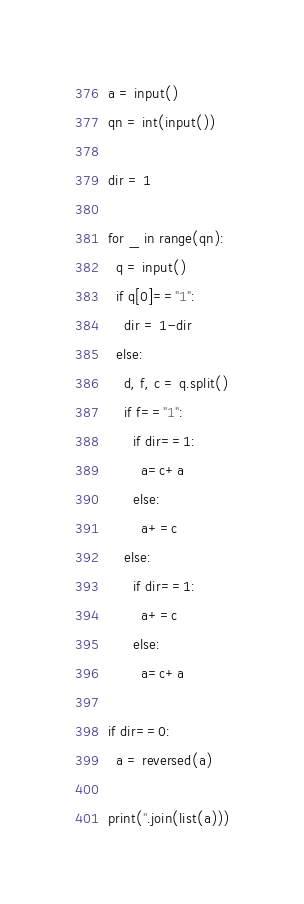Convert code to text. <code><loc_0><loc_0><loc_500><loc_500><_Python_>a = input()
qn = int(input())

dir = 1

for _ in range(qn):
  q = input()
  if q[0]=="1":
    dir = 1-dir
  else:
    d, f, c = q.split()
    if f=="1":
      if dir==1:
        a=c+a
      else:
        a+=c
    else:
      if dir==1:
        a+=c
      else:
        a=c+a

if dir==0:
  a = reversed(a)

print(''.join(list(a)))</code> 